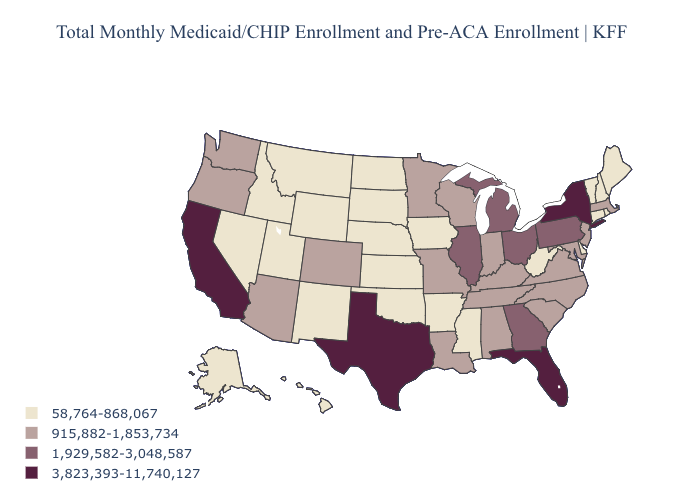What is the value of Arizona?
Quick response, please. 915,882-1,853,734. Which states have the highest value in the USA?
Concise answer only. California, Florida, New York, Texas. Name the states that have a value in the range 3,823,393-11,740,127?
Be succinct. California, Florida, New York, Texas. Does Rhode Island have the lowest value in the USA?
Quick response, please. Yes. Which states have the highest value in the USA?
Quick response, please. California, Florida, New York, Texas. What is the lowest value in the West?
Keep it brief. 58,764-868,067. Name the states that have a value in the range 3,823,393-11,740,127?
Quick response, please. California, Florida, New York, Texas. What is the highest value in the MidWest ?
Short answer required. 1,929,582-3,048,587. Name the states that have a value in the range 1,929,582-3,048,587?
Concise answer only. Georgia, Illinois, Michigan, Ohio, Pennsylvania. Does Utah have the lowest value in the USA?
Concise answer only. Yes. Name the states that have a value in the range 3,823,393-11,740,127?
Concise answer only. California, Florida, New York, Texas. Which states have the lowest value in the USA?
Concise answer only. Alaska, Arkansas, Connecticut, Delaware, Hawaii, Idaho, Iowa, Kansas, Maine, Mississippi, Montana, Nebraska, Nevada, New Hampshire, New Mexico, North Dakota, Oklahoma, Rhode Island, South Dakota, Utah, Vermont, West Virginia, Wyoming. What is the value of Nebraska?
Be succinct. 58,764-868,067. What is the value of Iowa?
Answer briefly. 58,764-868,067. Which states have the lowest value in the West?
Write a very short answer. Alaska, Hawaii, Idaho, Montana, Nevada, New Mexico, Utah, Wyoming. 